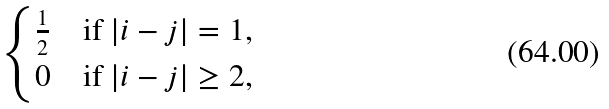Convert formula to latex. <formula><loc_0><loc_0><loc_500><loc_500>\begin{cases} \frac { 1 } { 2 } & \text {if } | i - j | = 1 , \\ 0 & \text {if} \ | i - j | \geq 2 , \end{cases}</formula> 